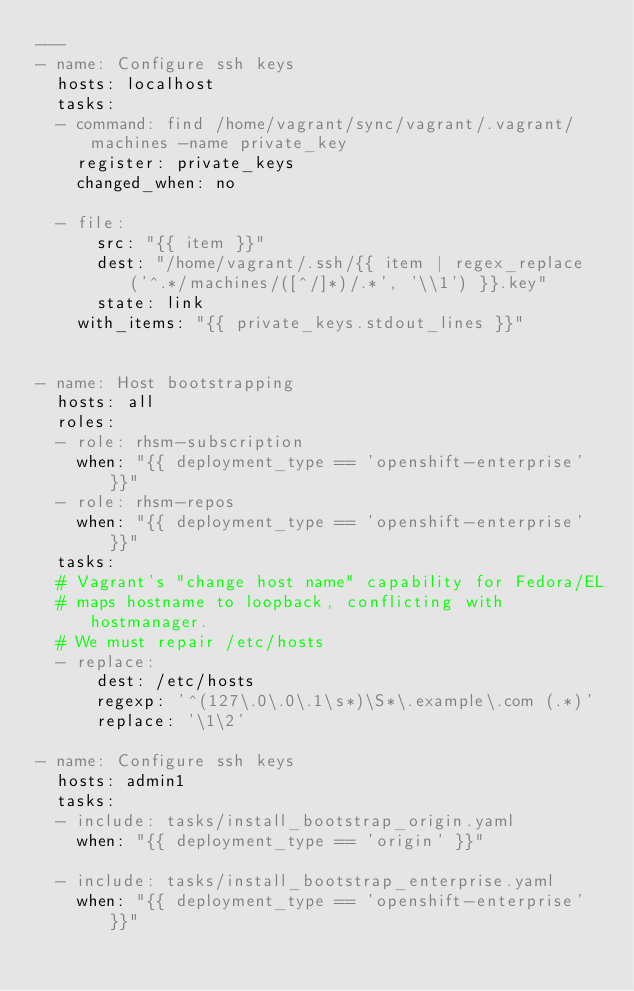Convert code to text. <code><loc_0><loc_0><loc_500><loc_500><_YAML_>---
- name: Configure ssh keys
  hosts: localhost
  tasks:
  - command: find /home/vagrant/sync/vagrant/.vagrant/machines -name private_key
    register: private_keys
    changed_when: no

  - file:
      src: "{{ item }}"
      dest: "/home/vagrant/.ssh/{{ item | regex_replace('^.*/machines/([^/]*)/.*', '\\1') }}.key"
      state: link
    with_items: "{{ private_keys.stdout_lines }}"


- name: Host bootstrapping
  hosts: all
  roles:
  - role: rhsm-subscription
    when: "{{ deployment_type == 'openshift-enterprise' }}"
  - role: rhsm-repos
    when: "{{ deployment_type == 'openshift-enterprise' }}"
  tasks:
  # Vagrant's "change host name" capability for Fedora/EL
  # maps hostname to loopback, conflicting with hostmanager.
  # We must repair /etc/hosts
  - replace:
      dest: /etc/hosts
      regexp: '^(127\.0\.0\.1\s*)\S*\.example\.com (.*)'
      replace: '\1\2'

- name: Configure ssh keys
  hosts: admin1
  tasks:
  - include: tasks/install_bootstrap_origin.yaml
    when: "{{ deployment_type == 'origin' }}"

  - include: tasks/install_bootstrap_enterprise.yaml
    when: "{{ deployment_type == 'openshift-enterprise' }}"
</code> 